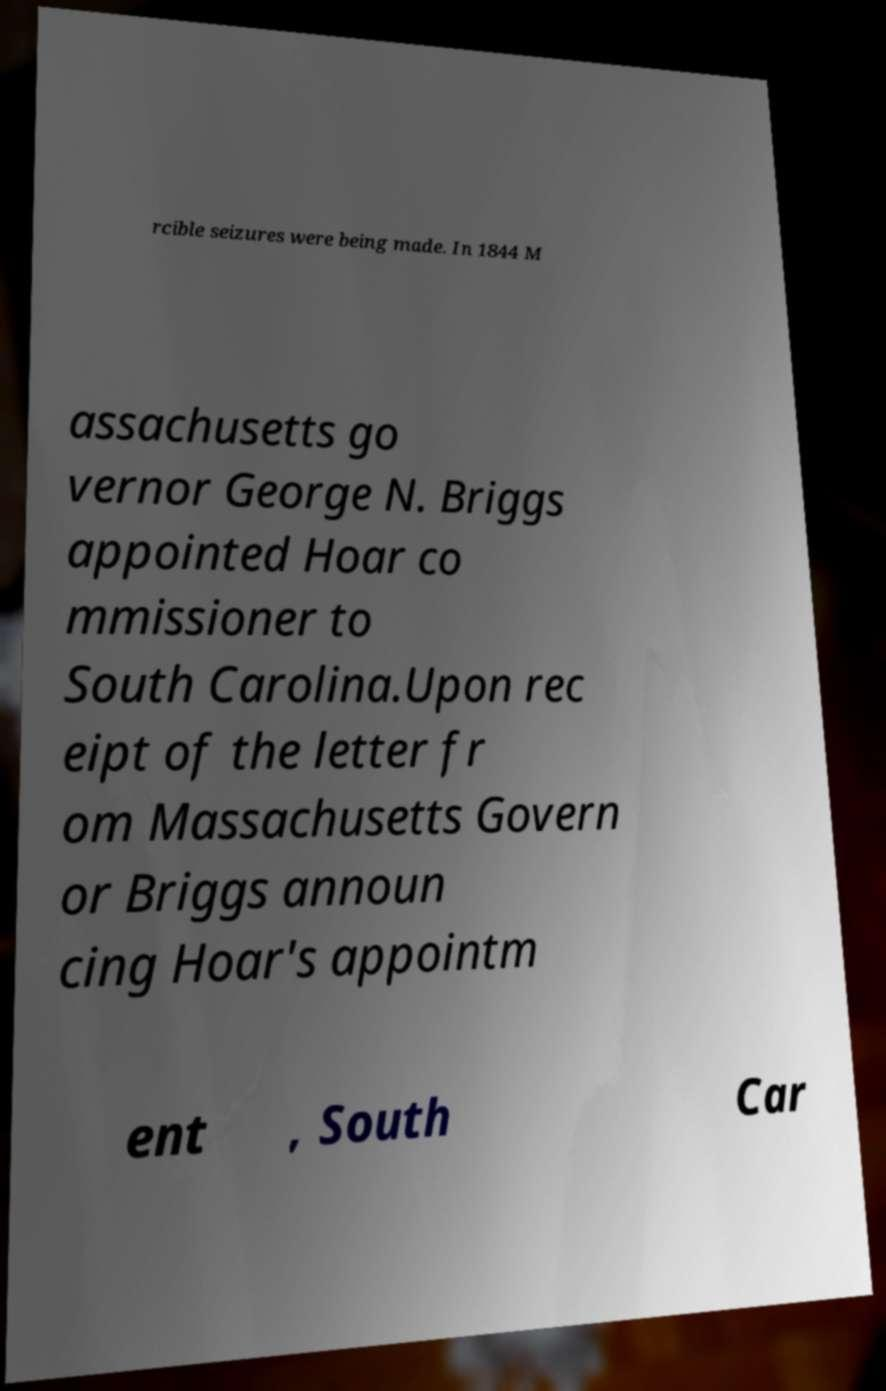Could you extract and type out the text from this image? rcible seizures were being made. In 1844 M assachusetts go vernor George N. Briggs appointed Hoar co mmissioner to South Carolina.Upon rec eipt of the letter fr om Massachusetts Govern or Briggs announ cing Hoar's appointm ent , South Car 